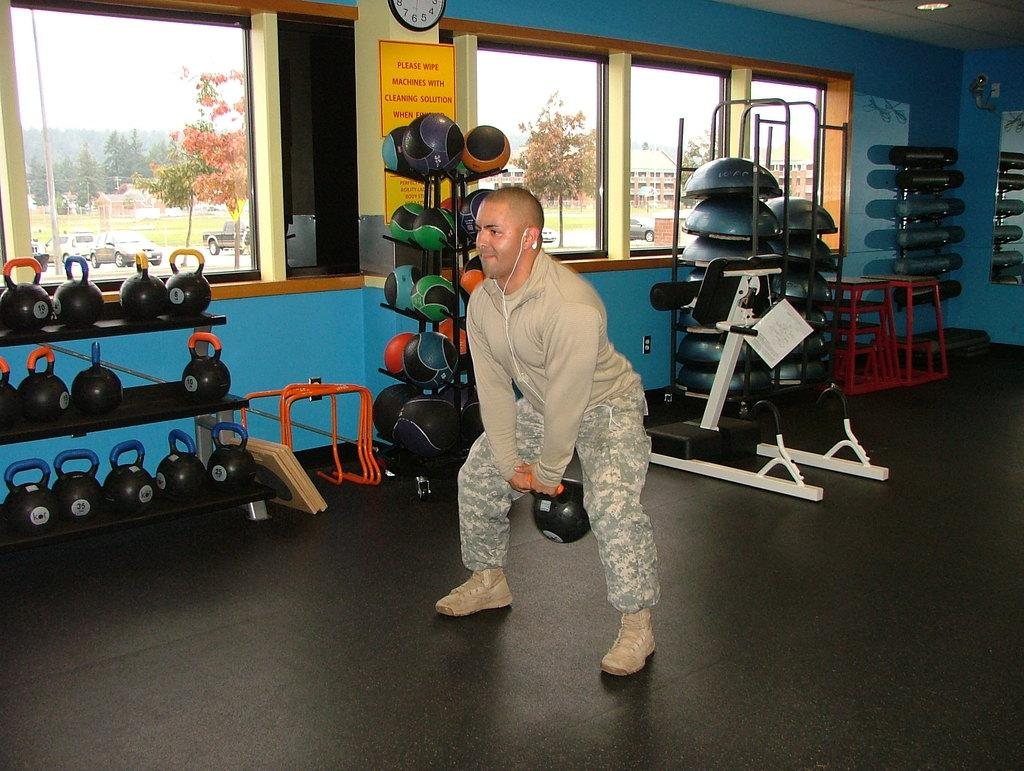<image>
Present a compact description of the photo's key features. the sign on the gym wall says Please wipe machines with cleaning solution 